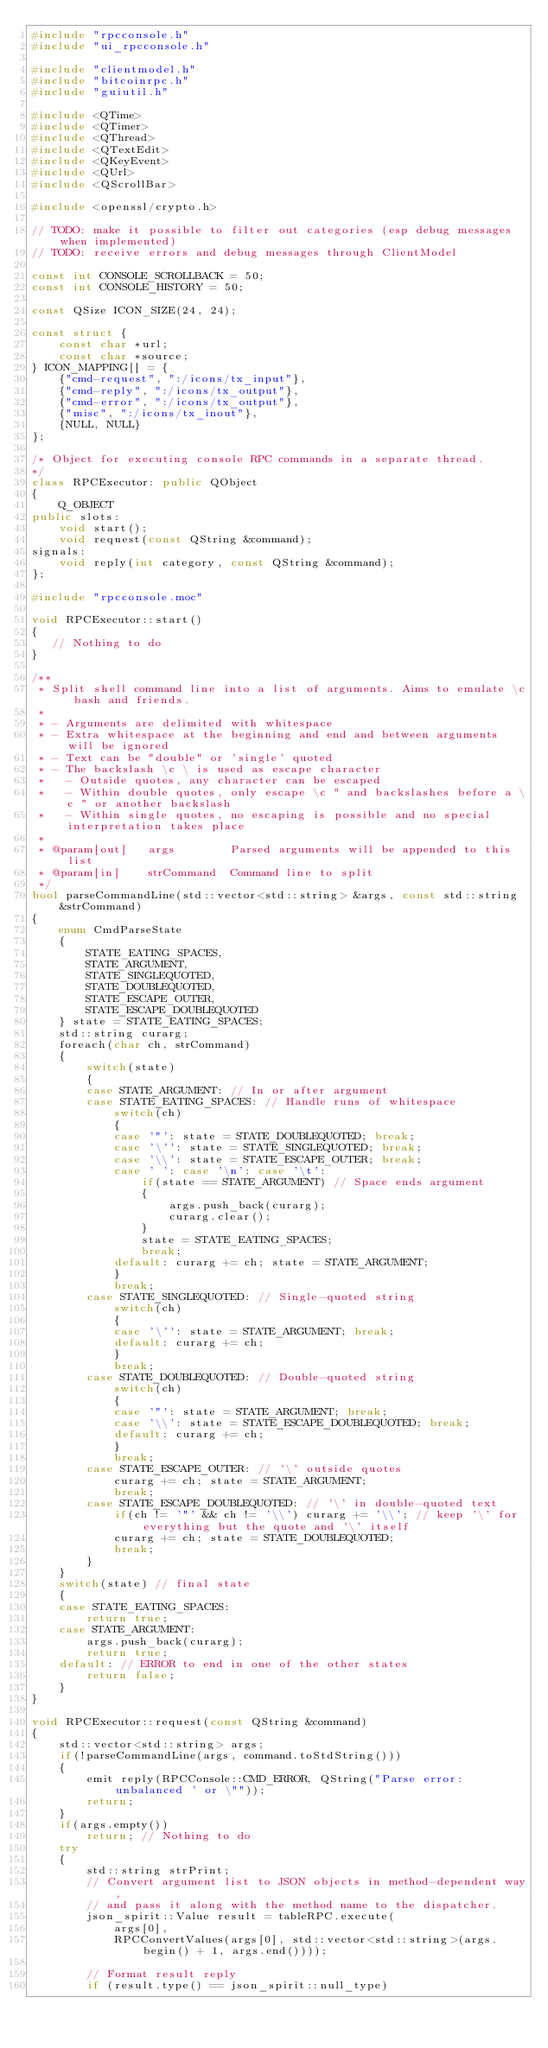<code> <loc_0><loc_0><loc_500><loc_500><_C++_>#include "rpcconsole.h"
#include "ui_rpcconsole.h"

#include "clientmodel.h"
#include "bitcoinrpc.h"
#include "guiutil.h"

#include <QTime>
#include <QTimer>
#include <QThread>
#include <QTextEdit>
#include <QKeyEvent>
#include <QUrl>
#include <QScrollBar>

#include <openssl/crypto.h>

// TODO: make it possible to filter out categories (esp debug messages when implemented)
// TODO: receive errors and debug messages through ClientModel

const int CONSOLE_SCROLLBACK = 50;
const int CONSOLE_HISTORY = 50;

const QSize ICON_SIZE(24, 24);

const struct {
    const char *url;
    const char *source;
} ICON_MAPPING[] = {
    {"cmd-request", ":/icons/tx_input"},
    {"cmd-reply", ":/icons/tx_output"},
    {"cmd-error", ":/icons/tx_output"},
    {"misc", ":/icons/tx_inout"},
    {NULL, NULL}
};

/* Object for executing console RPC commands in a separate thread.
*/
class RPCExecutor: public QObject
{
    Q_OBJECT
public slots:
    void start();
    void request(const QString &command);
signals:
    void reply(int category, const QString &command);
};

#include "rpcconsole.moc"

void RPCExecutor::start()
{
   // Nothing to do
}

/**
 * Split shell command line into a list of arguments. Aims to emulate \c bash and friends.
 *
 * - Arguments are delimited with whitespace
 * - Extra whitespace at the beginning and end and between arguments will be ignored
 * - Text can be "double" or 'single' quoted
 * - The backslash \c \ is used as escape character
 *   - Outside quotes, any character can be escaped
 *   - Within double quotes, only escape \c " and backslashes before a \c " or another backslash
 *   - Within single quotes, no escaping is possible and no special interpretation takes place
 *
 * @param[out]   args        Parsed arguments will be appended to this list
 * @param[in]    strCommand  Command line to split
 */
bool parseCommandLine(std::vector<std::string> &args, const std::string &strCommand)
{
    enum CmdParseState
    {
        STATE_EATING_SPACES,
        STATE_ARGUMENT,
        STATE_SINGLEQUOTED,
        STATE_DOUBLEQUOTED,
        STATE_ESCAPE_OUTER,
        STATE_ESCAPE_DOUBLEQUOTED
    } state = STATE_EATING_SPACES;
    std::string curarg;
    foreach(char ch, strCommand)
    {
        switch(state)
        {
        case STATE_ARGUMENT: // In or after argument
        case STATE_EATING_SPACES: // Handle runs of whitespace
            switch(ch)
            {
            case '"': state = STATE_DOUBLEQUOTED; break;
            case '\'': state = STATE_SINGLEQUOTED; break;
            case '\\': state = STATE_ESCAPE_OUTER; break;
            case ' ': case '\n': case '\t':
                if(state == STATE_ARGUMENT) // Space ends argument
                {
                    args.push_back(curarg);
                    curarg.clear();
                }
                state = STATE_EATING_SPACES;
                break;
            default: curarg += ch; state = STATE_ARGUMENT;
            }
            break;
        case STATE_SINGLEQUOTED: // Single-quoted string
            switch(ch)
            {
            case '\'': state = STATE_ARGUMENT; break;
            default: curarg += ch;
            }
            break;
        case STATE_DOUBLEQUOTED: // Double-quoted string
            switch(ch)
            {
            case '"': state = STATE_ARGUMENT; break;
            case '\\': state = STATE_ESCAPE_DOUBLEQUOTED; break;
            default: curarg += ch;
            }
            break;
        case STATE_ESCAPE_OUTER: // '\' outside quotes
            curarg += ch; state = STATE_ARGUMENT;
            break;
        case STATE_ESCAPE_DOUBLEQUOTED: // '\' in double-quoted text
            if(ch != '"' && ch != '\\') curarg += '\\'; // keep '\' for everything but the quote and '\' itself
            curarg += ch; state = STATE_DOUBLEQUOTED;
            break;
        }
    }
    switch(state) // final state
    {
    case STATE_EATING_SPACES:
        return true;
    case STATE_ARGUMENT:
        args.push_back(curarg);
        return true;
    default: // ERROR to end in one of the other states
        return false;
    }
}

void RPCExecutor::request(const QString &command)
{
    std::vector<std::string> args;
    if(!parseCommandLine(args, command.toStdString()))
    {
        emit reply(RPCConsole::CMD_ERROR, QString("Parse error: unbalanced ' or \""));
        return;
    }
    if(args.empty())
        return; // Nothing to do
    try
    {
        std::string strPrint;
        // Convert argument list to JSON objects in method-dependent way,
        // and pass it along with the method name to the dispatcher.
        json_spirit::Value result = tableRPC.execute(
            args[0],
            RPCConvertValues(args[0], std::vector<std::string>(args.begin() + 1, args.end())));

        // Format result reply
        if (result.type() == json_spirit::null_type)</code> 